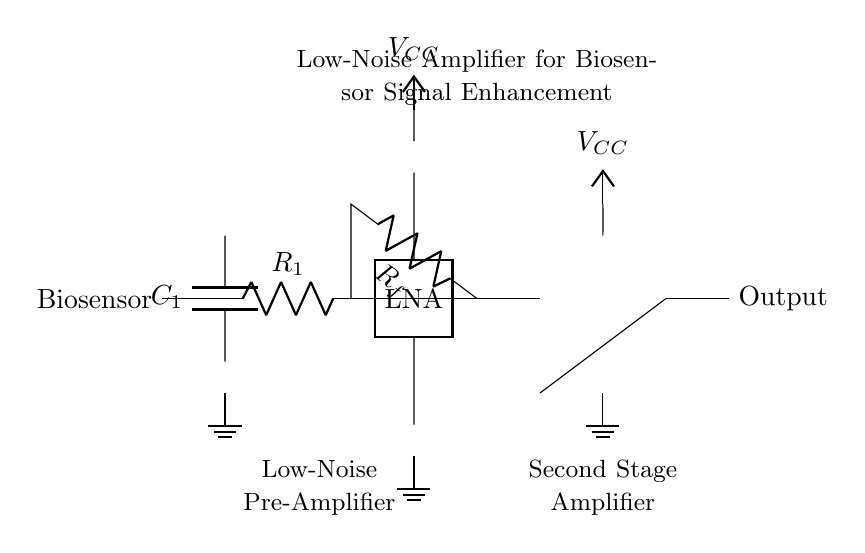What is the first component connected to the biosensor? The first component connected to the biosensor is a capacitor labeled C1, which is meant to filter or block unwanted high-frequency noise.
Answer: Capacitor C1 What type of amplifier is used in the first stage? The first stage of the amplifier is a low-noise amplifier, specifically designed to enhance weak signals without adding significant noise.
Answer: Low-noise amplifier What is the role of the resistor labeled Rf in the circuit? Resistor Rf is connected in feedback configuration, which helps stabilize the gain of the amplifier and improves linearity and bandwidth.
Answer: Feedback resistor What is the voltage supply used for the circuit? The voltage supply for the circuit is denoted as Vcc, which is typically a positive voltage source providing power to the amplifiers.
Answer: Vcc How many stages of amplification are present in this circuit? There are two stages of amplification depicted in the circuit: one low-noise pre-amplifier and one second stage amplifier.
Answer: Two stages What type of connection is made to the ground in this circuit? The ground connection is established through nodes marked as ground, ensuring a common reference point for the circuit voltages.
Answer: Ground connections What is the expected function of this amplifier circuit in healthcare? This amplifier circuit aims to enhance weak biosensor signals, making it easier to detect and analyze the presence of infectious disease biomarkers.
Answer: Signal enhancement 